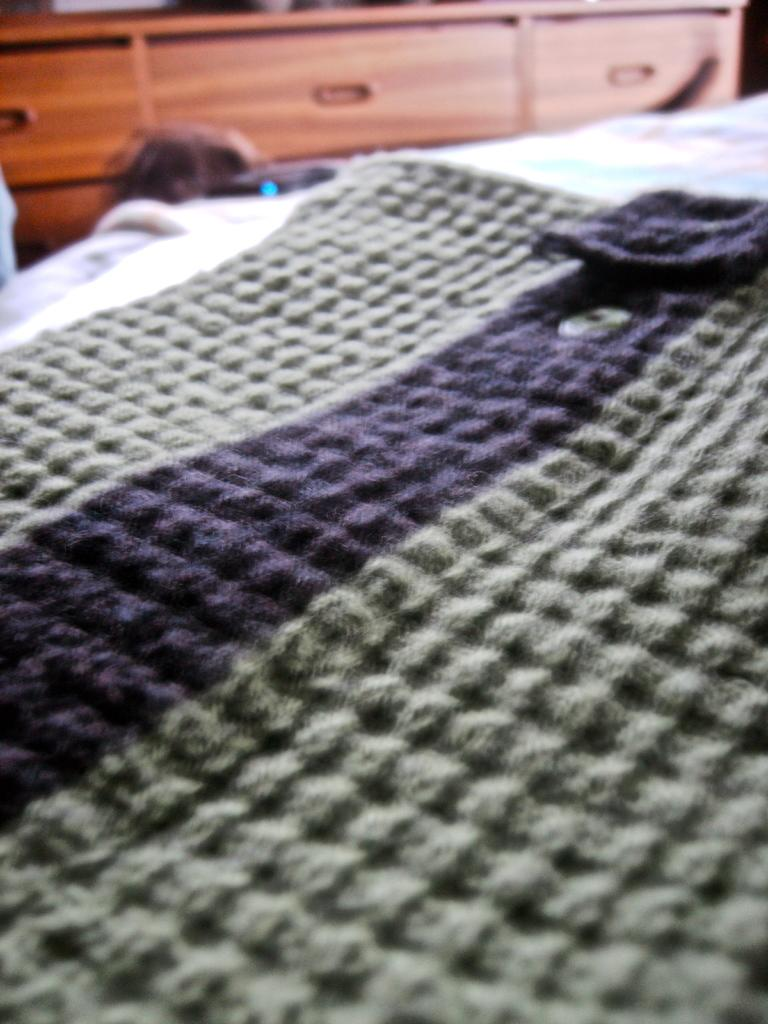What is placed on the bed in the image? There is a cloth on the bed. What type of furniture is present in the image? There are cupboards in the image. How many ducks are sitting on the cupboards in the image? There are no ducks present in the image; it only features a cloth on the bed and cupboards. What type of shade is covering the cupboards in the image? There is no shade covering the cupboards in the image; they are visible without any obstruction. 